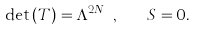Convert formula to latex. <formula><loc_0><loc_0><loc_500><loc_500>\det \left ( T \right ) = \Lambda ^ { 2 N _ { f } } , \quad S = 0 .</formula> 